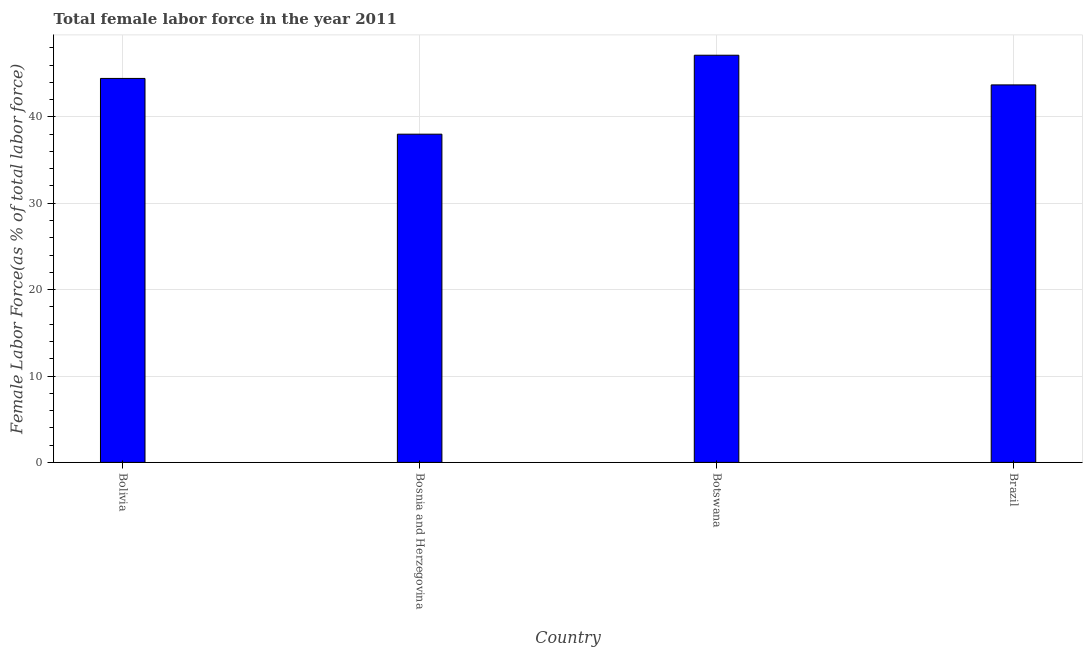Does the graph contain grids?
Offer a terse response. Yes. What is the title of the graph?
Make the answer very short. Total female labor force in the year 2011. What is the label or title of the Y-axis?
Provide a succinct answer. Female Labor Force(as % of total labor force). What is the total female labor force in Bosnia and Herzegovina?
Keep it short and to the point. 37.99. Across all countries, what is the maximum total female labor force?
Give a very brief answer. 47.13. Across all countries, what is the minimum total female labor force?
Your answer should be very brief. 37.99. In which country was the total female labor force maximum?
Make the answer very short. Botswana. In which country was the total female labor force minimum?
Make the answer very short. Bosnia and Herzegovina. What is the sum of the total female labor force?
Make the answer very short. 173.27. What is the difference between the total female labor force in Bosnia and Herzegovina and Botswana?
Offer a terse response. -9.14. What is the average total female labor force per country?
Provide a succinct answer. 43.32. What is the median total female labor force?
Provide a succinct answer. 44.07. What is the ratio of the total female labor force in Bolivia to that in Botswana?
Provide a short and direct response. 0.94. Is the total female labor force in Bolivia less than that in Brazil?
Keep it short and to the point. No. What is the difference between the highest and the second highest total female labor force?
Offer a terse response. 2.68. Is the sum of the total female labor force in Bolivia and Botswana greater than the maximum total female labor force across all countries?
Keep it short and to the point. Yes. What is the difference between the highest and the lowest total female labor force?
Provide a short and direct response. 9.14. In how many countries, is the total female labor force greater than the average total female labor force taken over all countries?
Provide a short and direct response. 3. How many bars are there?
Provide a succinct answer. 4. Are all the bars in the graph horizontal?
Your response must be concise. No. What is the Female Labor Force(as % of total labor force) of Bolivia?
Offer a very short reply. 44.45. What is the Female Labor Force(as % of total labor force) of Bosnia and Herzegovina?
Offer a very short reply. 37.99. What is the Female Labor Force(as % of total labor force) in Botswana?
Make the answer very short. 47.13. What is the Female Labor Force(as % of total labor force) of Brazil?
Your answer should be compact. 43.7. What is the difference between the Female Labor Force(as % of total labor force) in Bolivia and Bosnia and Herzegovina?
Offer a very short reply. 6.45. What is the difference between the Female Labor Force(as % of total labor force) in Bolivia and Botswana?
Your answer should be very brief. -2.68. What is the difference between the Female Labor Force(as % of total labor force) in Bolivia and Brazil?
Keep it short and to the point. 0.75. What is the difference between the Female Labor Force(as % of total labor force) in Bosnia and Herzegovina and Botswana?
Ensure brevity in your answer.  -9.14. What is the difference between the Female Labor Force(as % of total labor force) in Bosnia and Herzegovina and Brazil?
Offer a very short reply. -5.7. What is the difference between the Female Labor Force(as % of total labor force) in Botswana and Brazil?
Offer a very short reply. 3.43. What is the ratio of the Female Labor Force(as % of total labor force) in Bolivia to that in Bosnia and Herzegovina?
Offer a very short reply. 1.17. What is the ratio of the Female Labor Force(as % of total labor force) in Bolivia to that in Botswana?
Your response must be concise. 0.94. What is the ratio of the Female Labor Force(as % of total labor force) in Bosnia and Herzegovina to that in Botswana?
Provide a short and direct response. 0.81. What is the ratio of the Female Labor Force(as % of total labor force) in Bosnia and Herzegovina to that in Brazil?
Your response must be concise. 0.87. What is the ratio of the Female Labor Force(as % of total labor force) in Botswana to that in Brazil?
Provide a short and direct response. 1.08. 